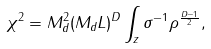Convert formula to latex. <formula><loc_0><loc_0><loc_500><loc_500>\chi ^ { 2 } = M ^ { 2 } _ { d } ( M _ { d } L ) ^ { D } \int _ { z } \sigma ^ { - 1 } \rho ^ { \frac { D - 1 } { 2 } } ,</formula> 